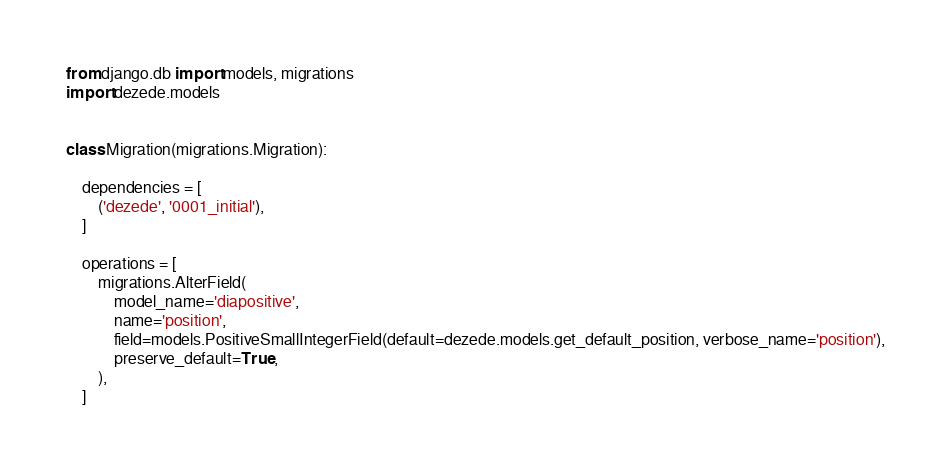Convert code to text. <code><loc_0><loc_0><loc_500><loc_500><_Python_>from django.db import models, migrations
import dezede.models


class Migration(migrations.Migration):

    dependencies = [
        ('dezede', '0001_initial'),
    ]

    operations = [
        migrations.AlterField(
            model_name='diapositive',
            name='position',
            field=models.PositiveSmallIntegerField(default=dezede.models.get_default_position, verbose_name='position'),
            preserve_default=True,
        ),
    ]
</code> 